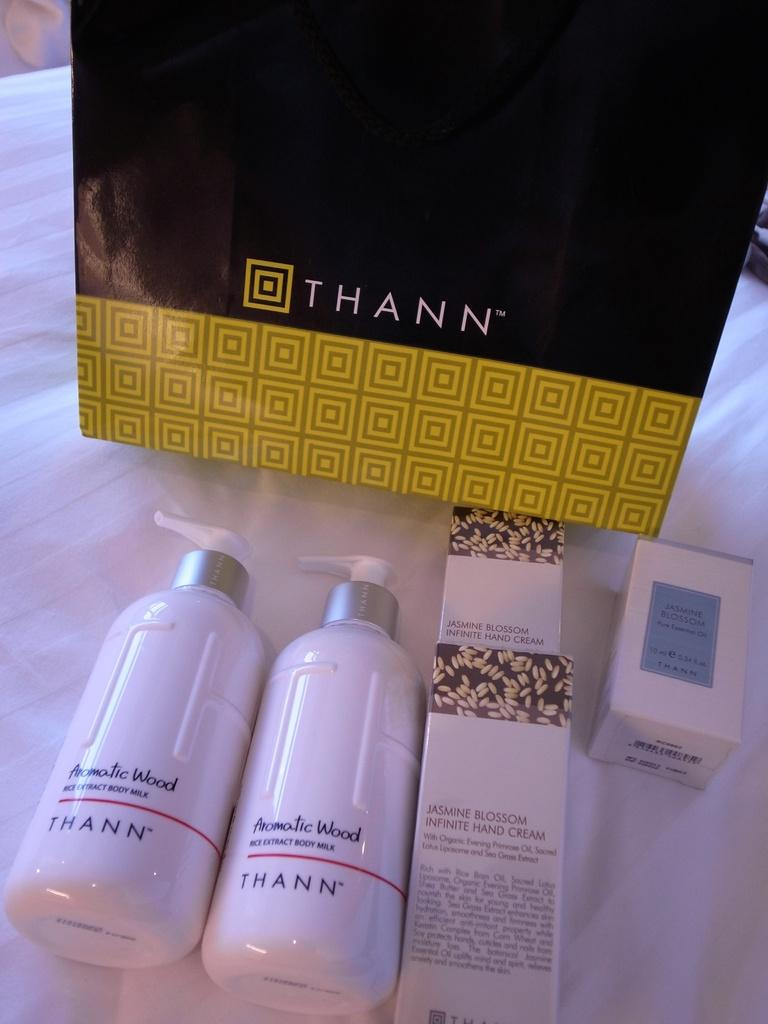Provide a one-sentence caption for the provided image. Thann beauty products placed in front of a Thann bag. 